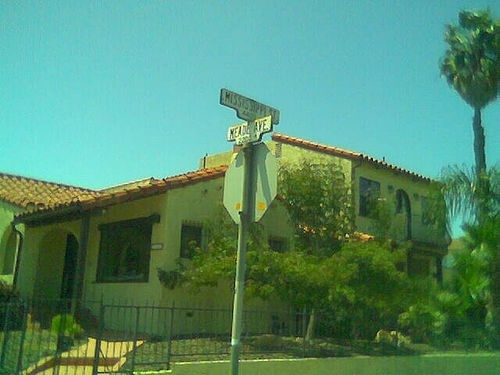Describe the objects in this image and their specific colors. I can see a stop sign in turquoise, green, lightgreen, and darkgreen tones in this image. 